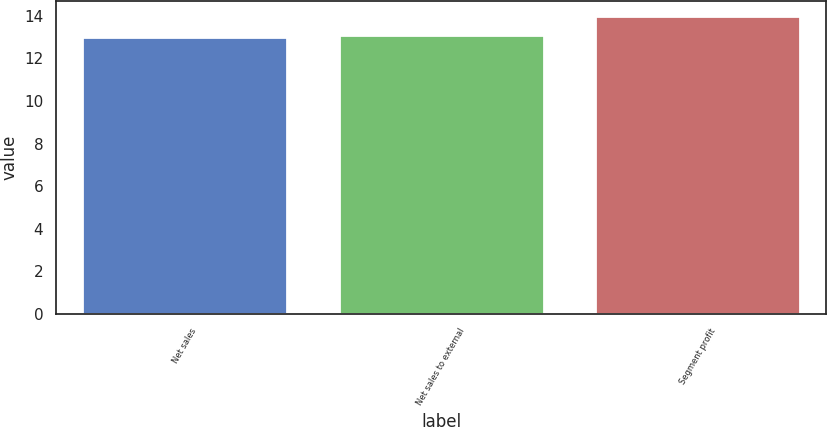Convert chart. <chart><loc_0><loc_0><loc_500><loc_500><bar_chart><fcel>Net sales<fcel>Net sales to external<fcel>Segment profit<nl><fcel>13<fcel>13.1<fcel>14<nl></chart> 